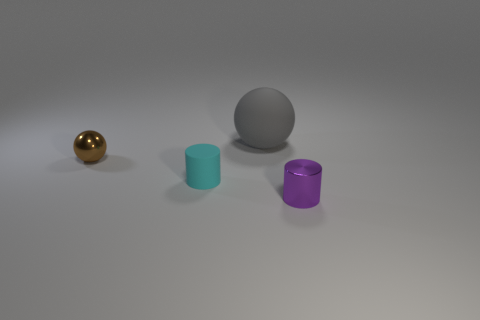Add 3 green metallic things. How many objects exist? 7 Subtract all tiny brown shiny balls. Subtract all cyan things. How many objects are left? 2 Add 4 small rubber things. How many small rubber things are left? 5 Add 1 tiny cyan rubber things. How many tiny cyan rubber things exist? 2 Subtract 0 green blocks. How many objects are left? 4 